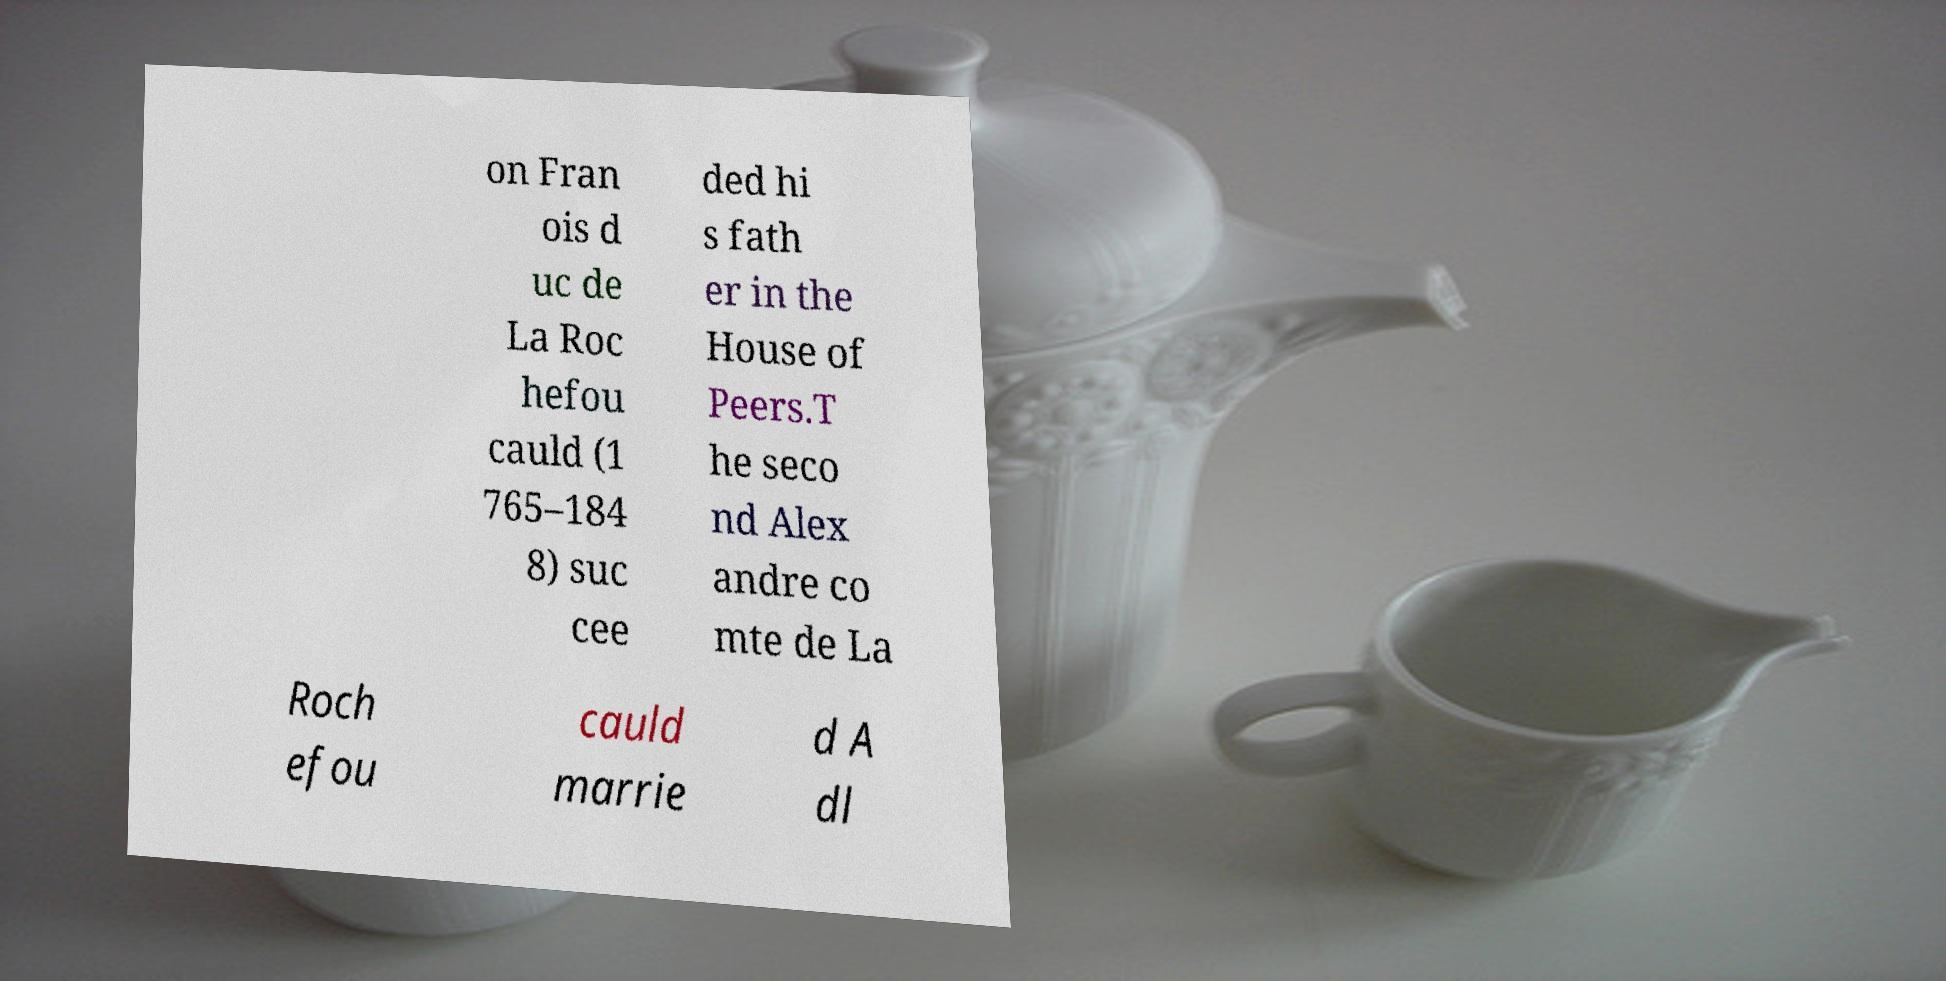Please read and relay the text visible in this image. What does it say? on Fran ois d uc de La Roc hefou cauld (1 765–184 8) suc cee ded hi s fath er in the House of Peers.T he seco nd Alex andre co mte de La Roch efou cauld marrie d A dl 